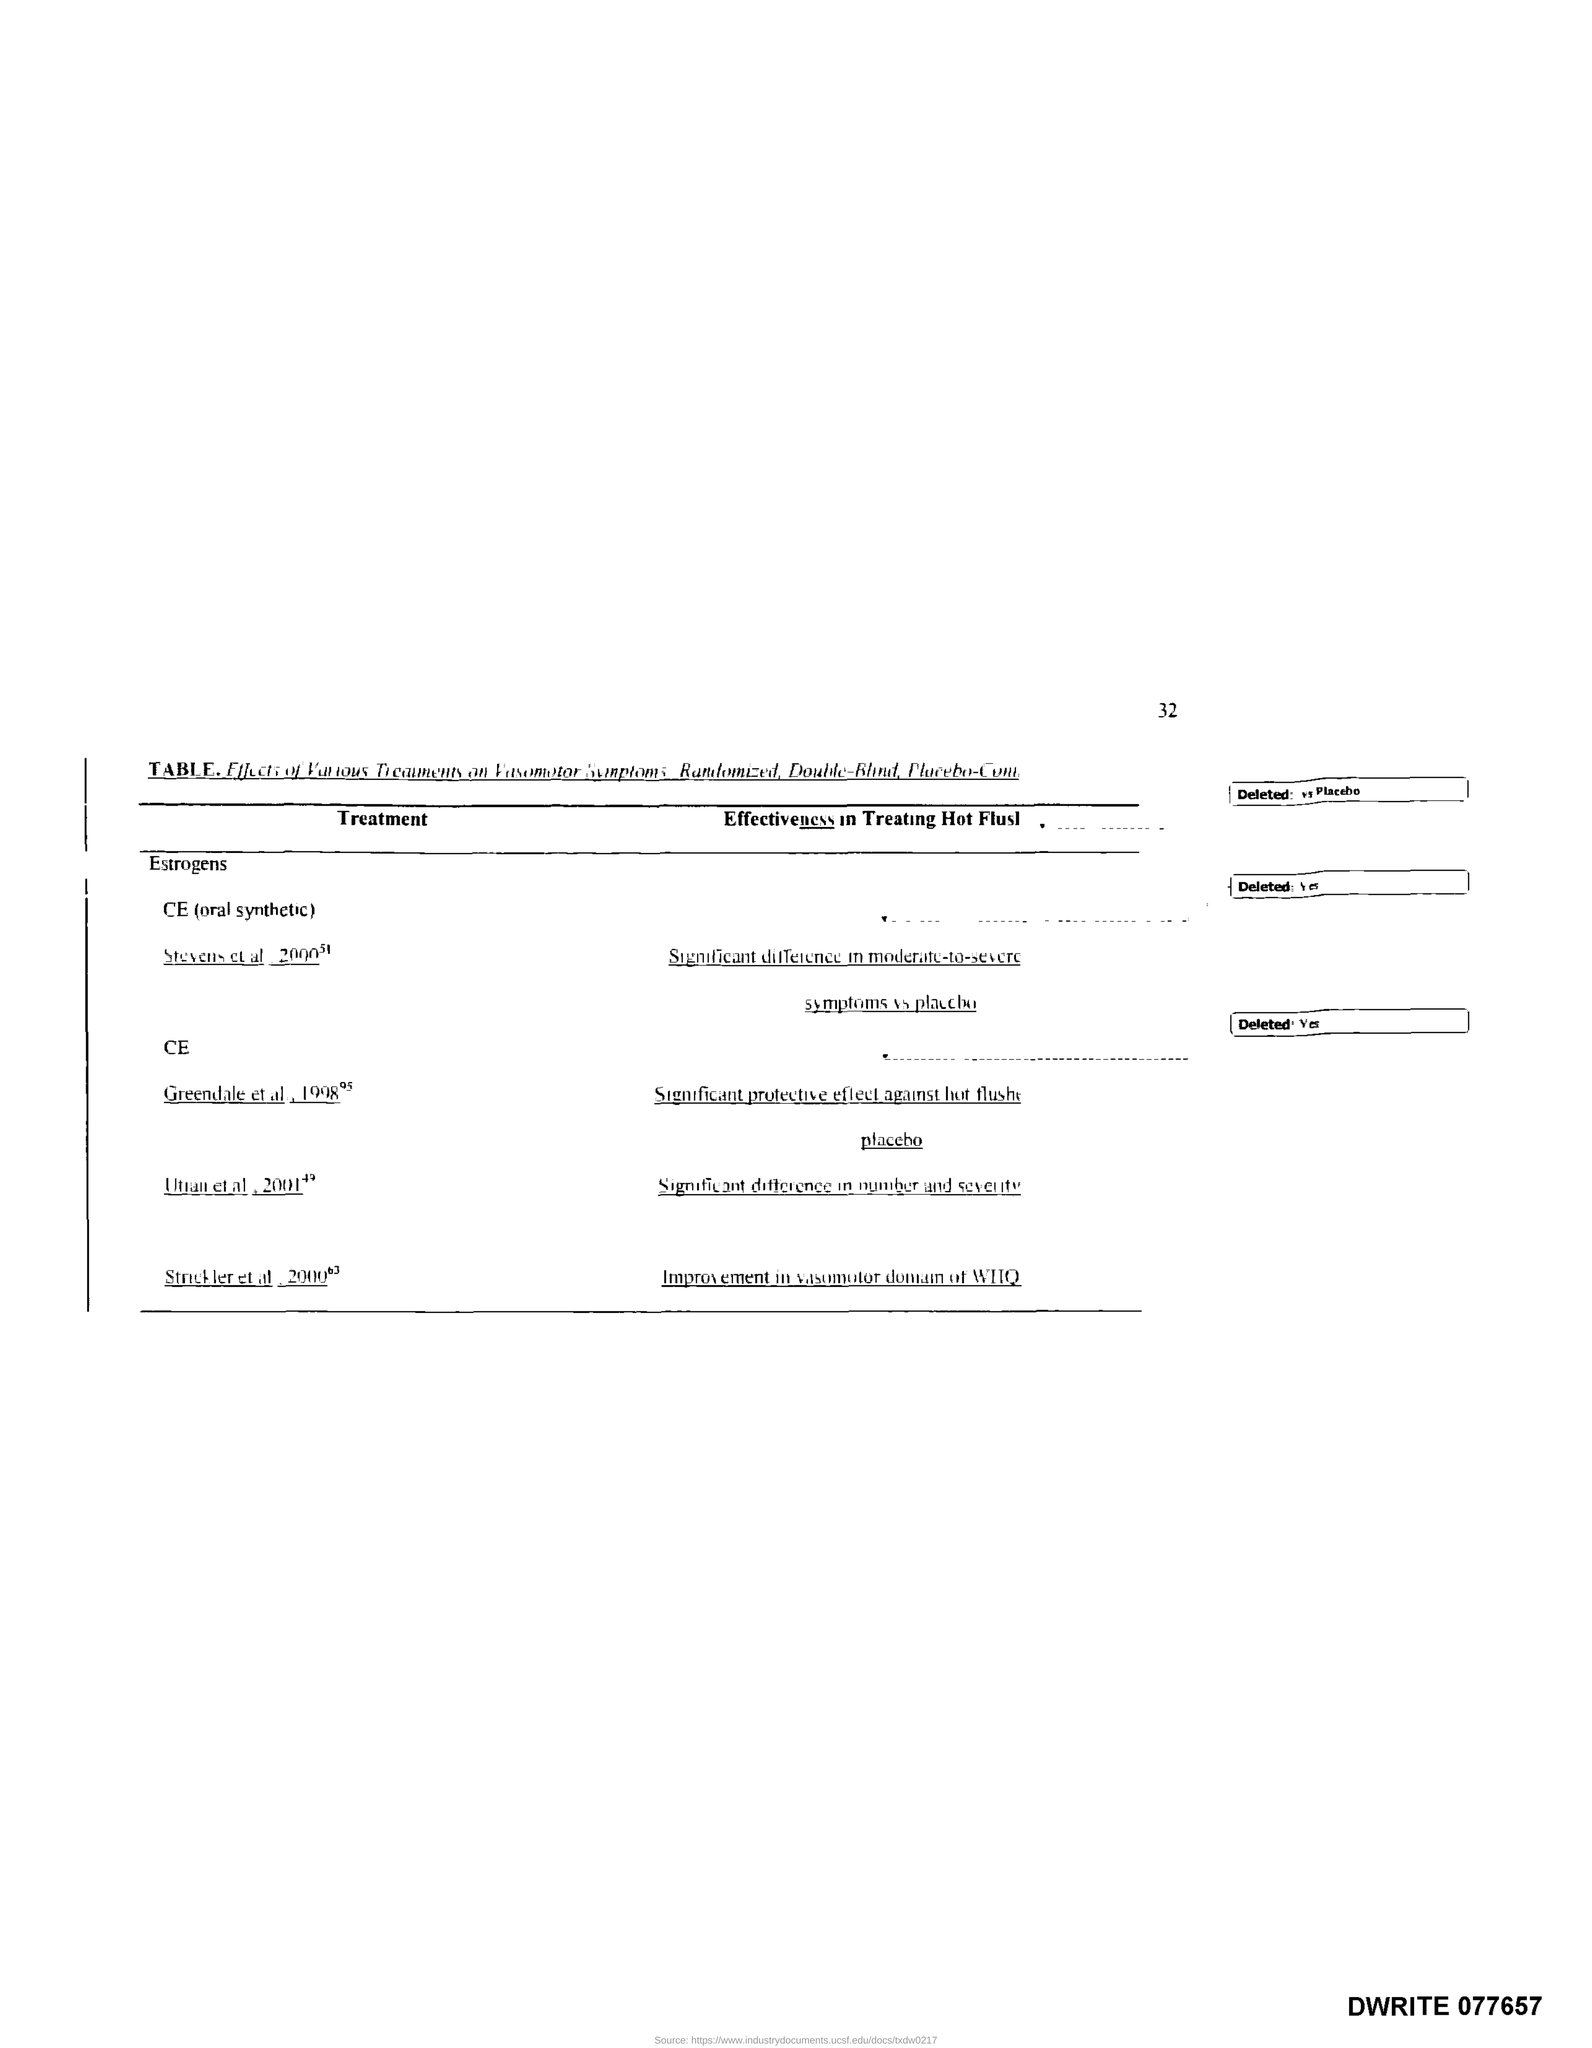What is the Page Number?
Make the answer very short. 32. 